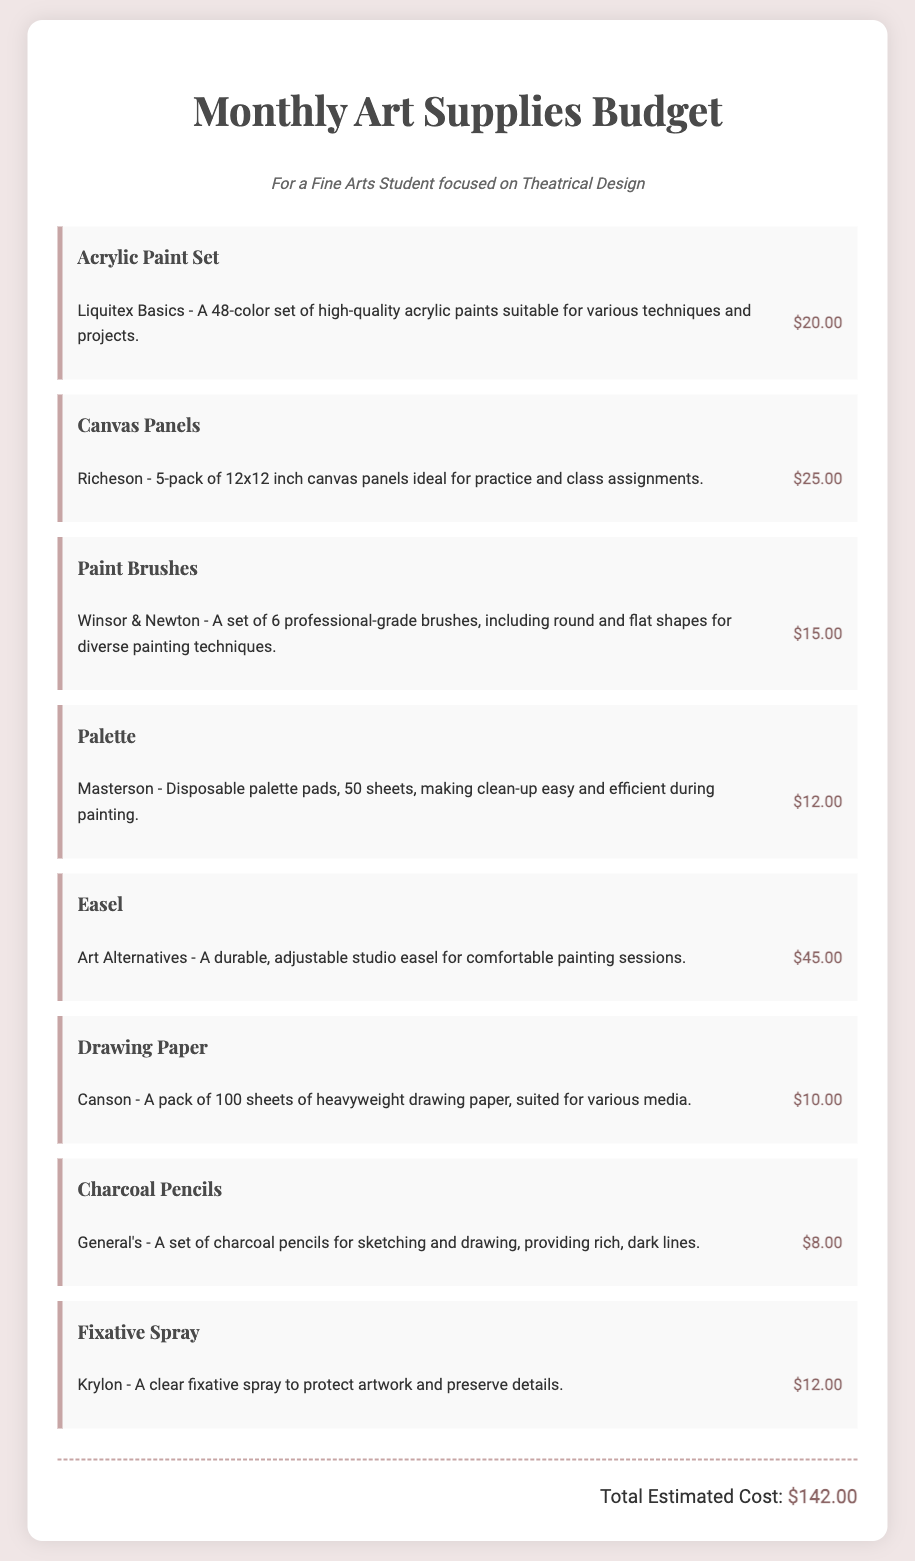what is the total estimated cost? The total estimated cost is stated at the end of the document, which sums up all the individual item costs.
Answer: $142.00 how many colors are in the acrylic paint set? The acrylic paint set includes a total of 48 different colors.
Answer: 48 what type of easel is mentioned? The document specifies a durable, adjustable studio easel.
Answer: adjustable studio easel which brand is the drawing paper from? The drawing paper is mentioned to be from the Canson brand, as specified in the document.
Answer: Canson how many sheets does the palette pad contain? The disposable palette pads contain 50 sheets, according to the details in the document.
Answer: 50 sheets what is the price of the paint brushes? The document lists the price of the paint brushes as $15.00.
Answer: $15.00 which item is priced the highest? By comparing the prices listed, the easel is identified as the highest priced item at $45.00.
Answer: Easel what is the primary purpose of the fixative spray? The fixative spray's purpose, as mentioned, is to protect artwork and preserve details.
Answer: protect artwork how many canvas panels are included in the pack? The document states that the pack contains 5 canvas panels.
Answer: 5 panels 